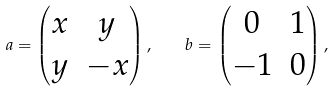Convert formula to latex. <formula><loc_0><loc_0><loc_500><loc_500>a = \left ( \begin{matrix} x & y \\ y & - x \end{matrix} \right ) , \quad b = \left ( \begin{matrix} 0 & 1 \\ - 1 & 0 \end{matrix} \right ) ,</formula> 